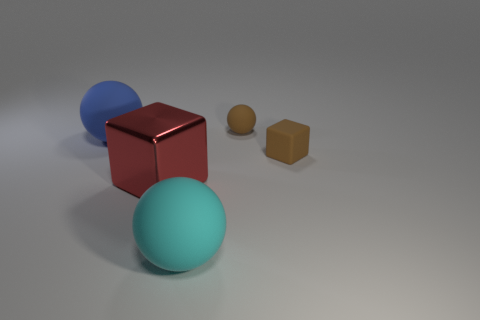Are the cyan object and the brown object behind the small block made of the same material?
Make the answer very short. Yes. The big ball in front of the small brown object that is in front of the small brown object behind the blue matte object is what color?
Offer a very short reply. Cyan. What is the material of the ball that is the same size as the cyan matte thing?
Provide a succinct answer. Rubber. How many large cyan balls are the same material as the big blue thing?
Offer a very short reply. 1. Is the size of the block to the right of the cyan rubber sphere the same as the brown object that is behind the blue ball?
Provide a succinct answer. Yes. What color is the large ball in front of the big blue matte sphere?
Provide a succinct answer. Cyan. How many spheres are the same color as the small block?
Your answer should be very brief. 1. Does the red thing have the same size as the ball that is left of the cyan thing?
Your answer should be compact. Yes. There is a rubber thing that is left of the rubber sphere that is in front of the brown object that is on the right side of the brown matte sphere; how big is it?
Make the answer very short. Large. There is a big red cube; what number of big red things are left of it?
Give a very brief answer. 0. 